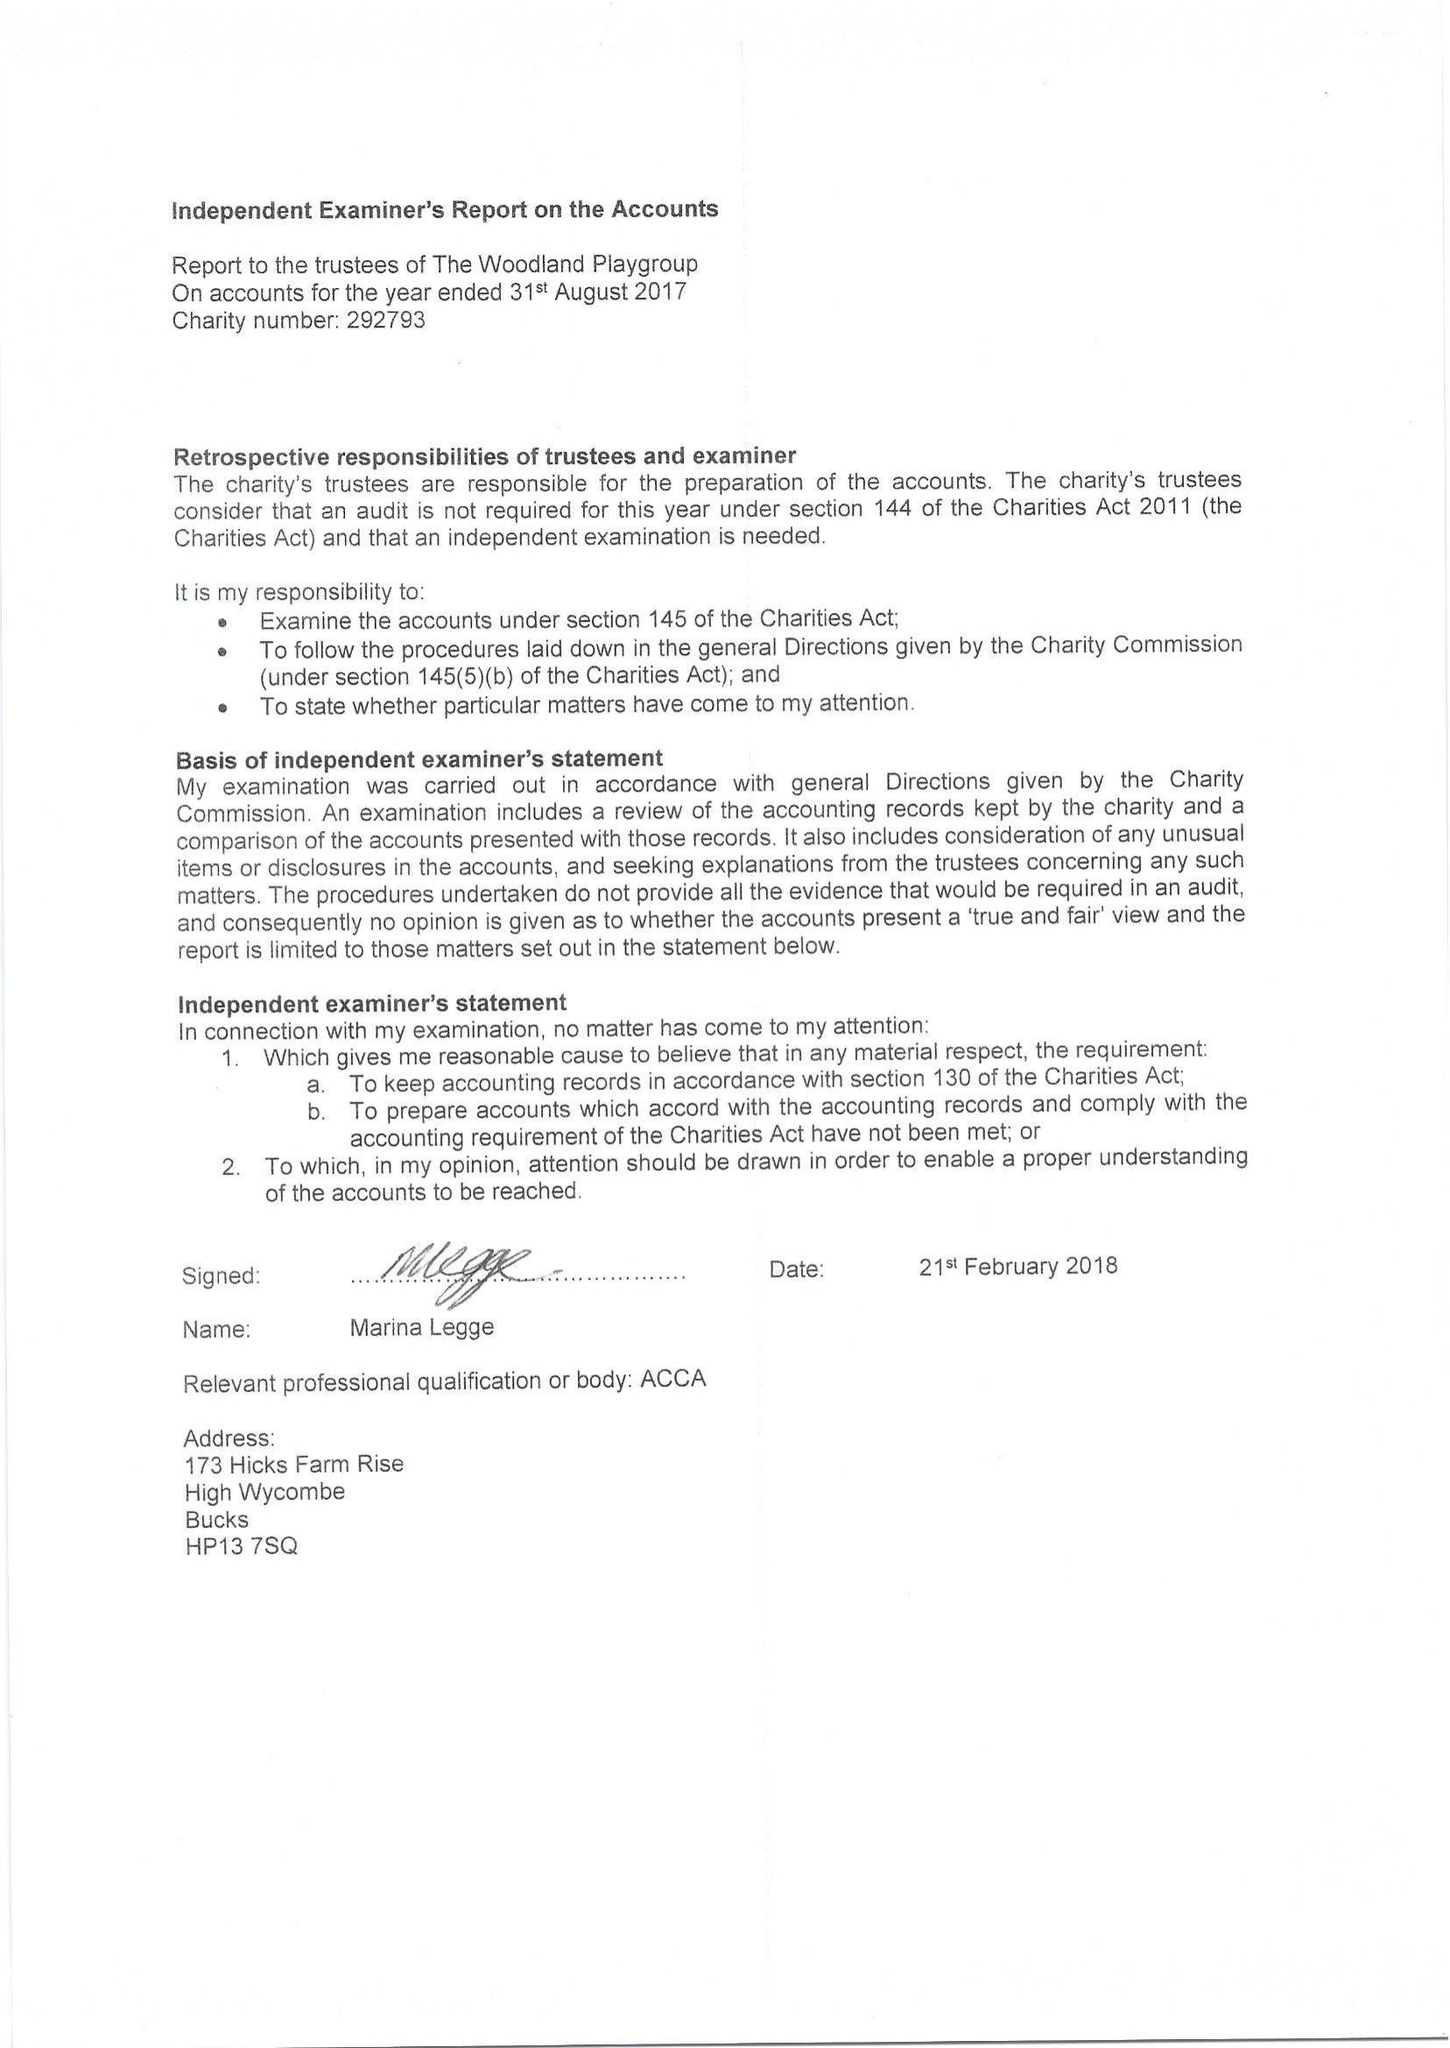What is the value for the address__postcode?
Answer the question using a single word or phrase. HP13 5UX 